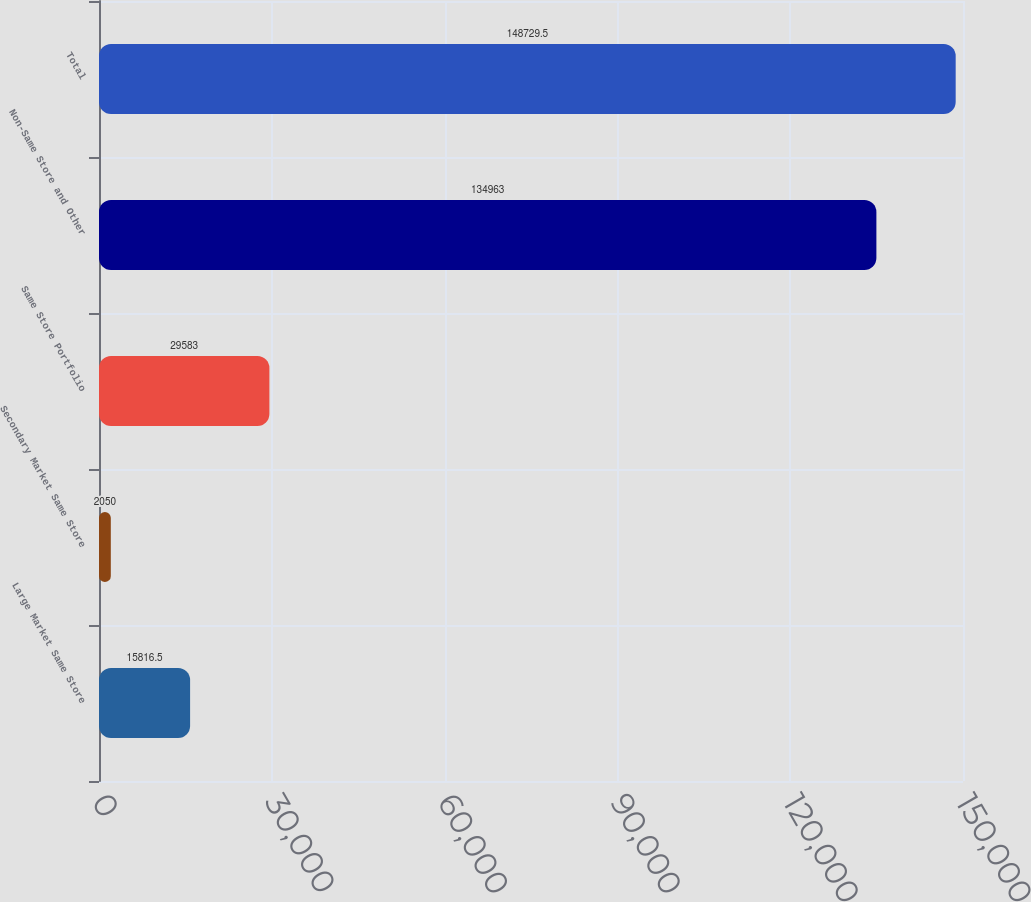Convert chart to OTSL. <chart><loc_0><loc_0><loc_500><loc_500><bar_chart><fcel>Large Market Same Store<fcel>Secondary Market Same Store<fcel>Same Store Portfolio<fcel>Non-Same Store and Other<fcel>Total<nl><fcel>15816.5<fcel>2050<fcel>29583<fcel>134963<fcel>148730<nl></chart> 